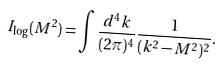<formula> <loc_0><loc_0><loc_500><loc_500>I _ { \log } ( M ^ { 2 } ) = \int \frac { d ^ { 4 } k } { ( 2 \pi ) ^ { 4 } } \frac { 1 } { ( k ^ { 2 } - M ^ { 2 } ) ^ { 2 } } .</formula> 